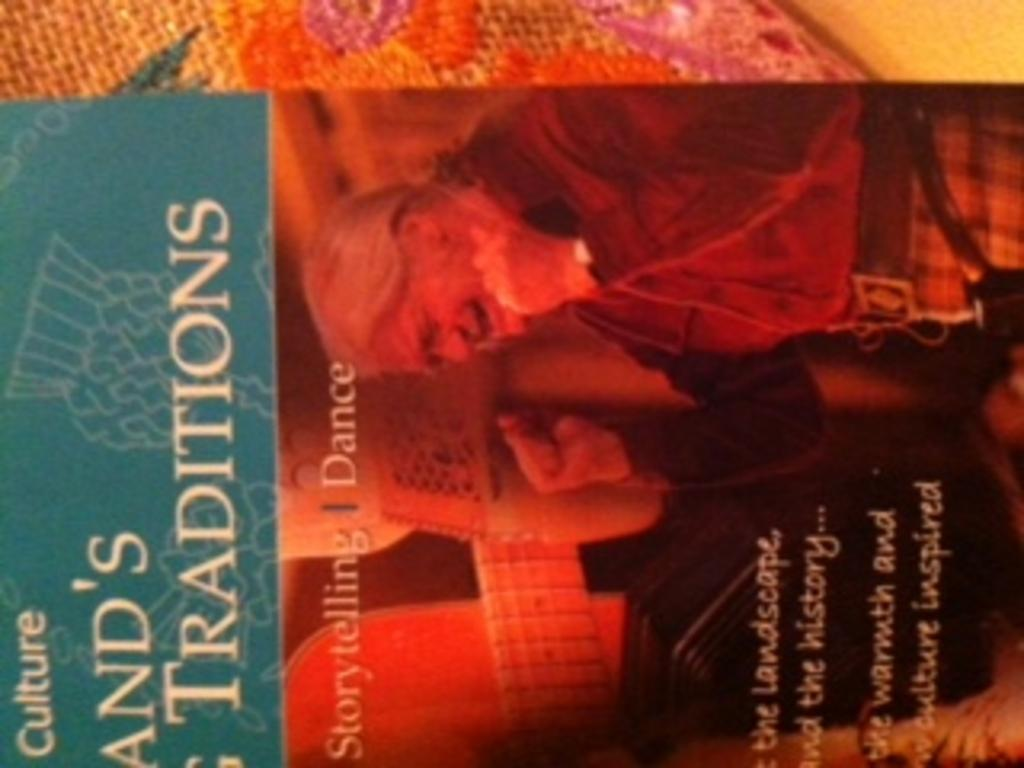<image>
Render a clear and concise summary of the photo. Half of a book cover that advertises storytelling and dance. 